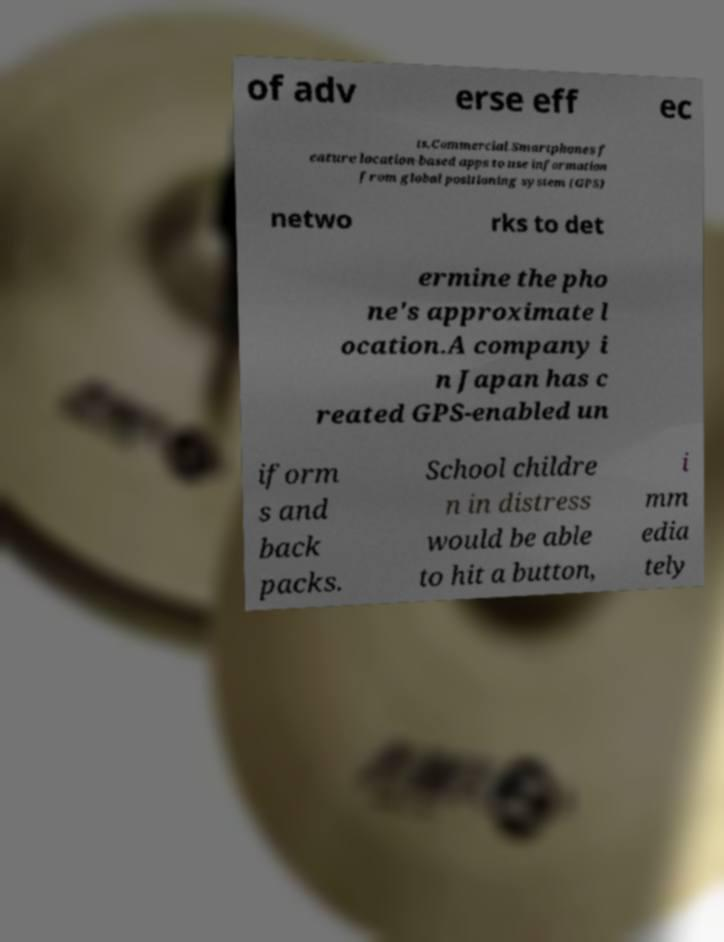For documentation purposes, I need the text within this image transcribed. Could you provide that? of adv erse eff ec ts.Commercial.Smartphones f eature location-based apps to use information from global positioning system (GPS) netwo rks to det ermine the pho ne's approximate l ocation.A company i n Japan has c reated GPS-enabled un iform s and back packs. School childre n in distress would be able to hit a button, i mm edia tely 